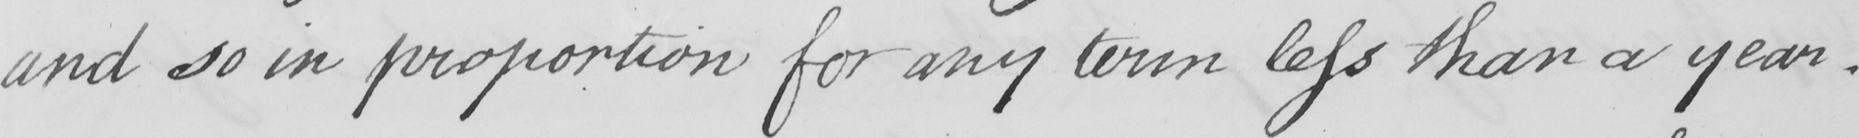Can you read and transcribe this handwriting? and so in proportion for any term less than a year . 